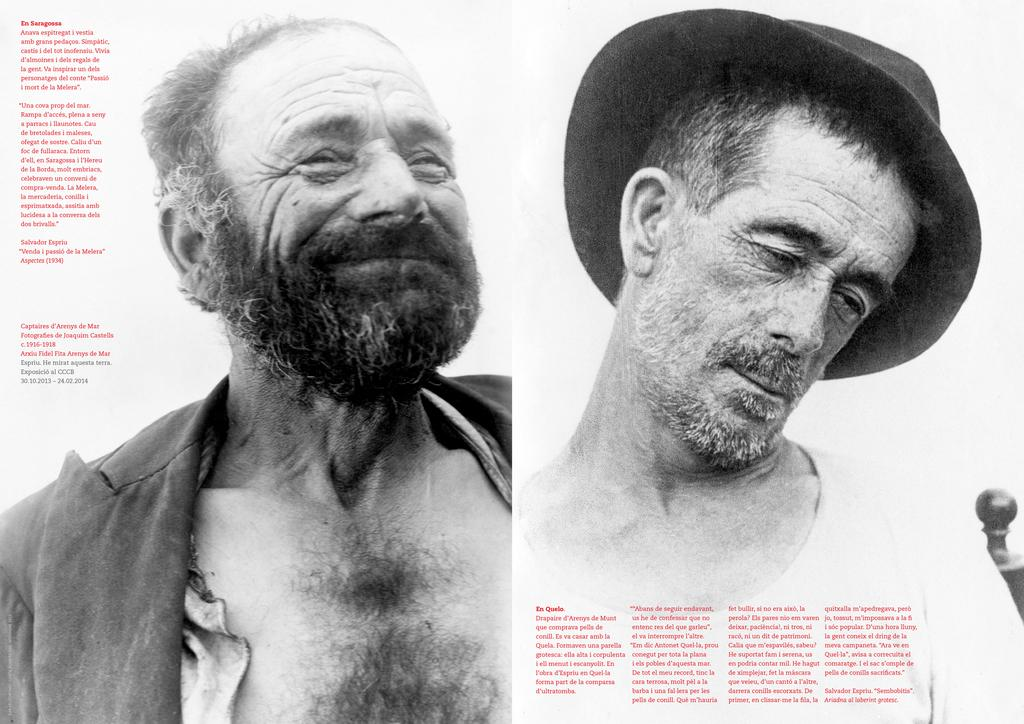What is featured on the poster in the image? The poster has pictures of two persons and some text. Can you describe the people depicted on the poster? The poster contains pictures of two persons, but we cannot determine their specific features from the image. What else is present on the poster besides the images of the persons? The poster also contains some text. What can be seen on the right side of the image? There is a person wearing a cap on the right side of the image. How many matches are being held by the person on the left side of the image? There is no person holding matches in the image; it only features a poster and a person wearing a cap on the right side. 